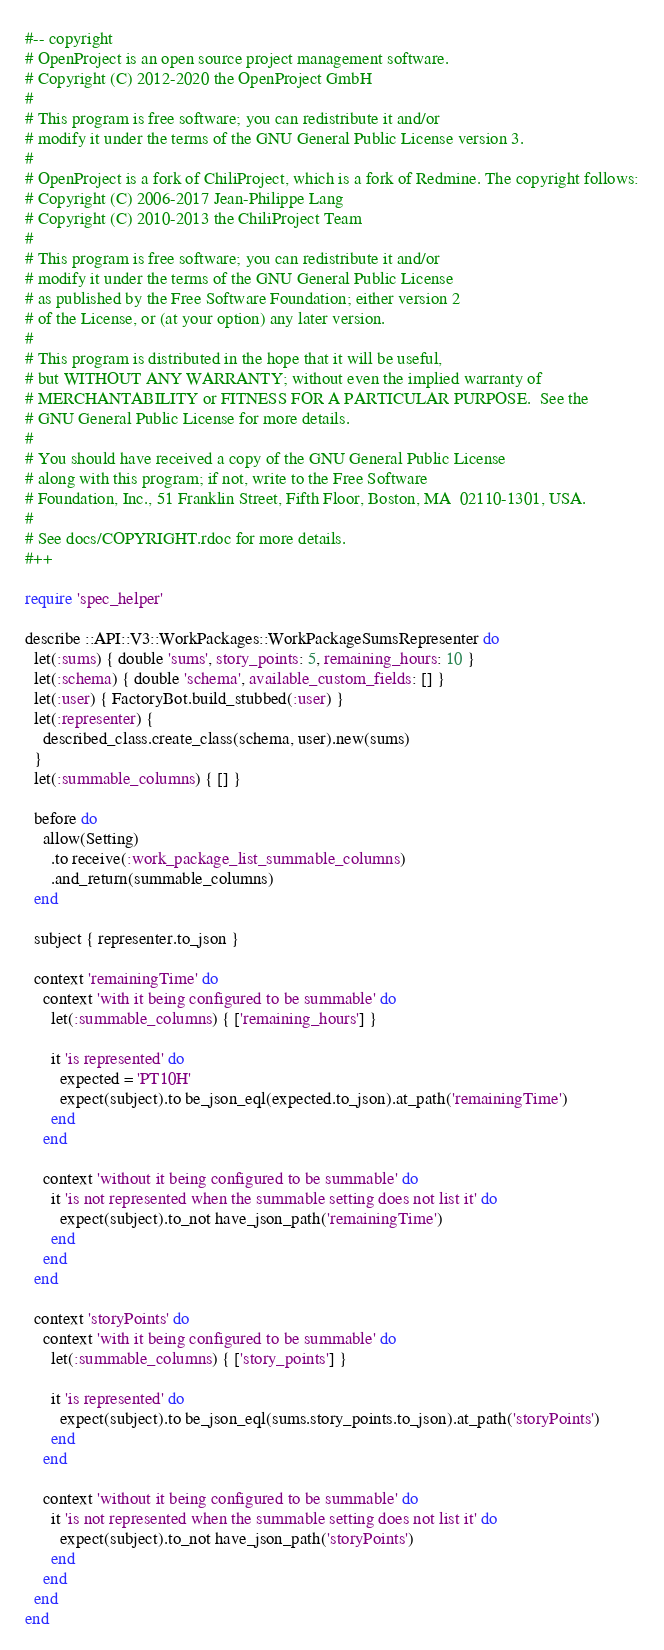<code> <loc_0><loc_0><loc_500><loc_500><_Ruby_>#-- copyright
# OpenProject is an open source project management software.
# Copyright (C) 2012-2020 the OpenProject GmbH
#
# This program is free software; you can redistribute it and/or
# modify it under the terms of the GNU General Public License version 3.
#
# OpenProject is a fork of ChiliProject, which is a fork of Redmine. The copyright follows:
# Copyright (C) 2006-2017 Jean-Philippe Lang
# Copyright (C) 2010-2013 the ChiliProject Team
#
# This program is free software; you can redistribute it and/or
# modify it under the terms of the GNU General Public License
# as published by the Free Software Foundation; either version 2
# of the License, or (at your option) any later version.
#
# This program is distributed in the hope that it will be useful,
# but WITHOUT ANY WARRANTY; without even the implied warranty of
# MERCHANTABILITY or FITNESS FOR A PARTICULAR PURPOSE.  See the
# GNU General Public License for more details.
#
# You should have received a copy of the GNU General Public License
# along with this program; if not, write to the Free Software
# Foundation, Inc., 51 Franklin Street, Fifth Floor, Boston, MA  02110-1301, USA.
#
# See docs/COPYRIGHT.rdoc for more details.
#++

require 'spec_helper'

describe ::API::V3::WorkPackages::WorkPackageSumsRepresenter do
  let(:sums) { double 'sums', story_points: 5, remaining_hours: 10 }
  let(:schema) { double 'schema', available_custom_fields: [] }
  let(:user) { FactoryBot.build_stubbed(:user) }
  let(:representer) {
    described_class.create_class(schema, user).new(sums)
  }
  let(:summable_columns) { [] }

  before do
    allow(Setting)
      .to receive(:work_package_list_summable_columns)
      .and_return(summable_columns)
  end

  subject { representer.to_json }

  context 'remainingTime' do
    context 'with it being configured to be summable' do
      let(:summable_columns) { ['remaining_hours'] }

      it 'is represented' do
        expected = 'PT10H'
        expect(subject).to be_json_eql(expected.to_json).at_path('remainingTime')
      end
    end

    context 'without it being configured to be summable' do
      it 'is not represented when the summable setting does not list it' do
        expect(subject).to_not have_json_path('remainingTime')
      end
    end
  end

  context 'storyPoints' do
    context 'with it being configured to be summable' do
      let(:summable_columns) { ['story_points'] }

      it 'is represented' do
        expect(subject).to be_json_eql(sums.story_points.to_json).at_path('storyPoints')
      end
    end

    context 'without it being configured to be summable' do
      it 'is not represented when the summable setting does not list it' do
        expect(subject).to_not have_json_path('storyPoints')
      end
    end
  end
end
</code> 